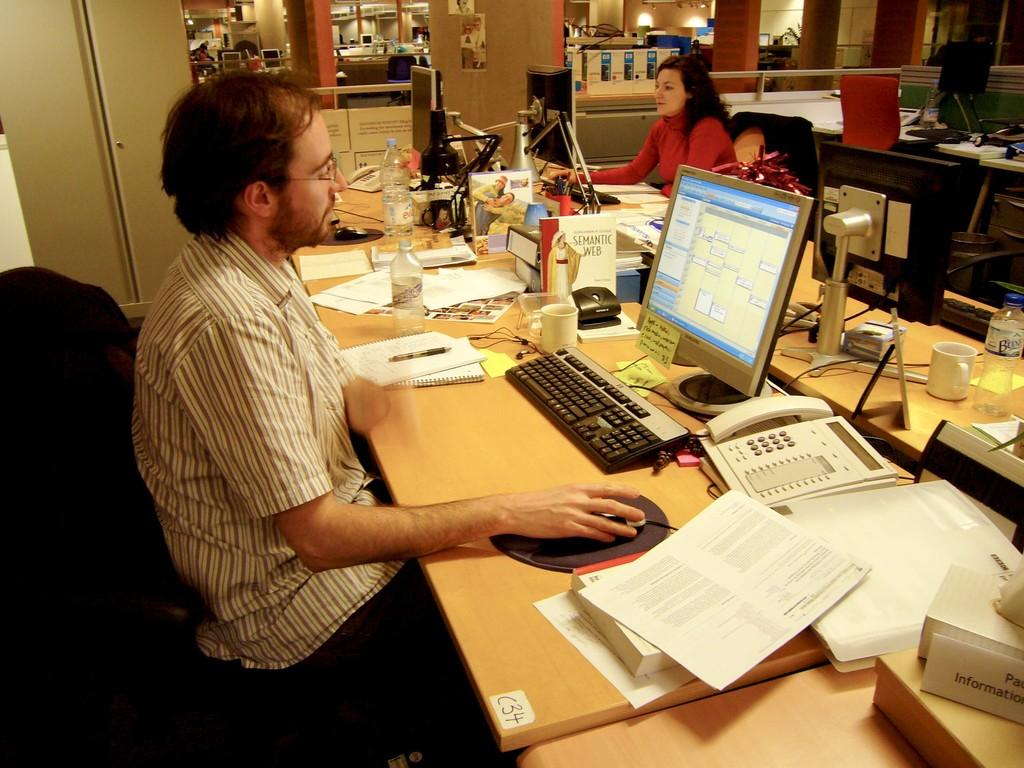<image>
Summarize the visual content of the image. A man wearing a striped white shirt sits in front of a computer at desk C34. 